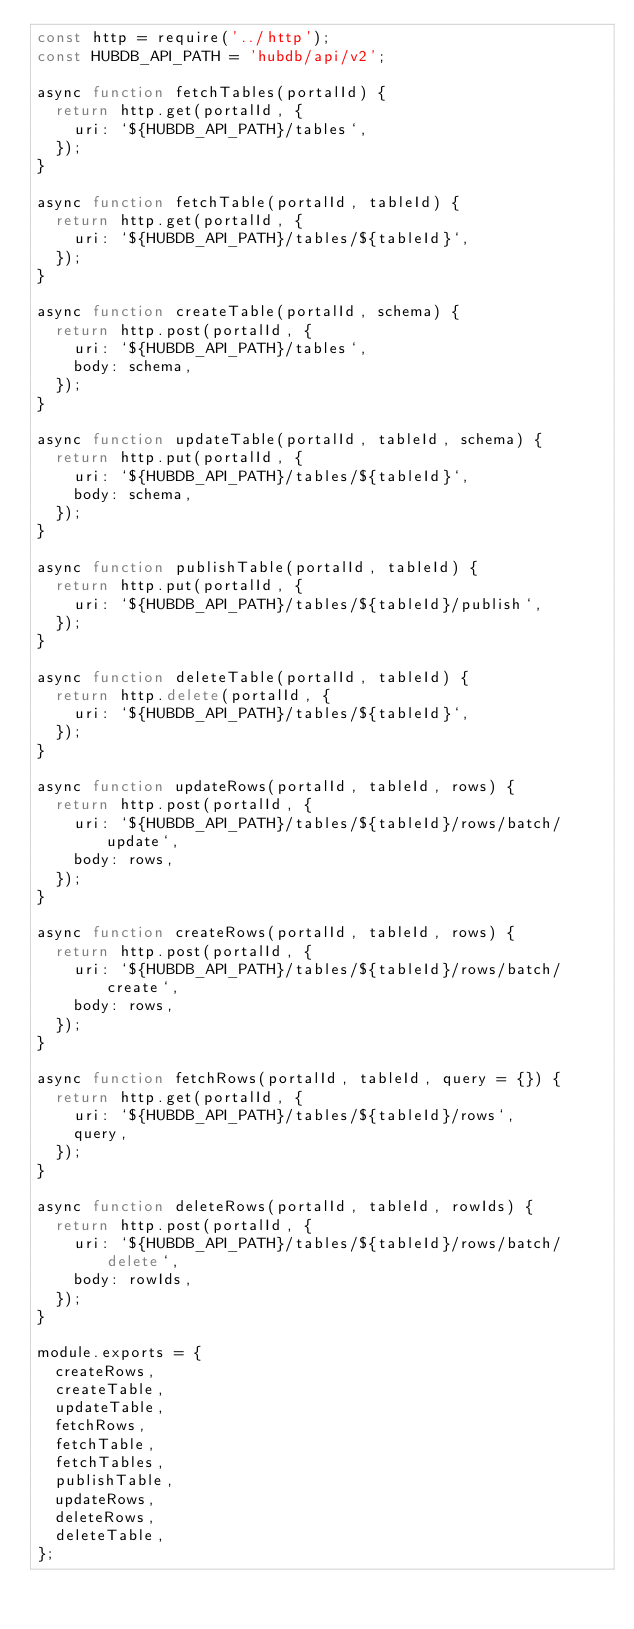Convert code to text. <code><loc_0><loc_0><loc_500><loc_500><_JavaScript_>const http = require('../http');
const HUBDB_API_PATH = 'hubdb/api/v2';

async function fetchTables(portalId) {
  return http.get(portalId, {
    uri: `${HUBDB_API_PATH}/tables`,
  });
}

async function fetchTable(portalId, tableId) {
  return http.get(portalId, {
    uri: `${HUBDB_API_PATH}/tables/${tableId}`,
  });
}

async function createTable(portalId, schema) {
  return http.post(portalId, {
    uri: `${HUBDB_API_PATH}/tables`,
    body: schema,
  });
}

async function updateTable(portalId, tableId, schema) {
  return http.put(portalId, {
    uri: `${HUBDB_API_PATH}/tables/${tableId}`,
    body: schema,
  });
}

async function publishTable(portalId, tableId) {
  return http.put(portalId, {
    uri: `${HUBDB_API_PATH}/tables/${tableId}/publish`,
  });
}

async function deleteTable(portalId, tableId) {
  return http.delete(portalId, {
    uri: `${HUBDB_API_PATH}/tables/${tableId}`,
  });
}

async function updateRows(portalId, tableId, rows) {
  return http.post(portalId, {
    uri: `${HUBDB_API_PATH}/tables/${tableId}/rows/batch/update`,
    body: rows,
  });
}

async function createRows(portalId, tableId, rows) {
  return http.post(portalId, {
    uri: `${HUBDB_API_PATH}/tables/${tableId}/rows/batch/create`,
    body: rows,
  });
}

async function fetchRows(portalId, tableId, query = {}) {
  return http.get(portalId, {
    uri: `${HUBDB_API_PATH}/tables/${tableId}/rows`,
    query,
  });
}

async function deleteRows(portalId, tableId, rowIds) {
  return http.post(portalId, {
    uri: `${HUBDB_API_PATH}/tables/${tableId}/rows/batch/delete`,
    body: rowIds,
  });
}

module.exports = {
  createRows,
  createTable,
  updateTable,
  fetchRows,
  fetchTable,
  fetchTables,
  publishTable,
  updateRows,
  deleteRows,
  deleteTable,
};
</code> 